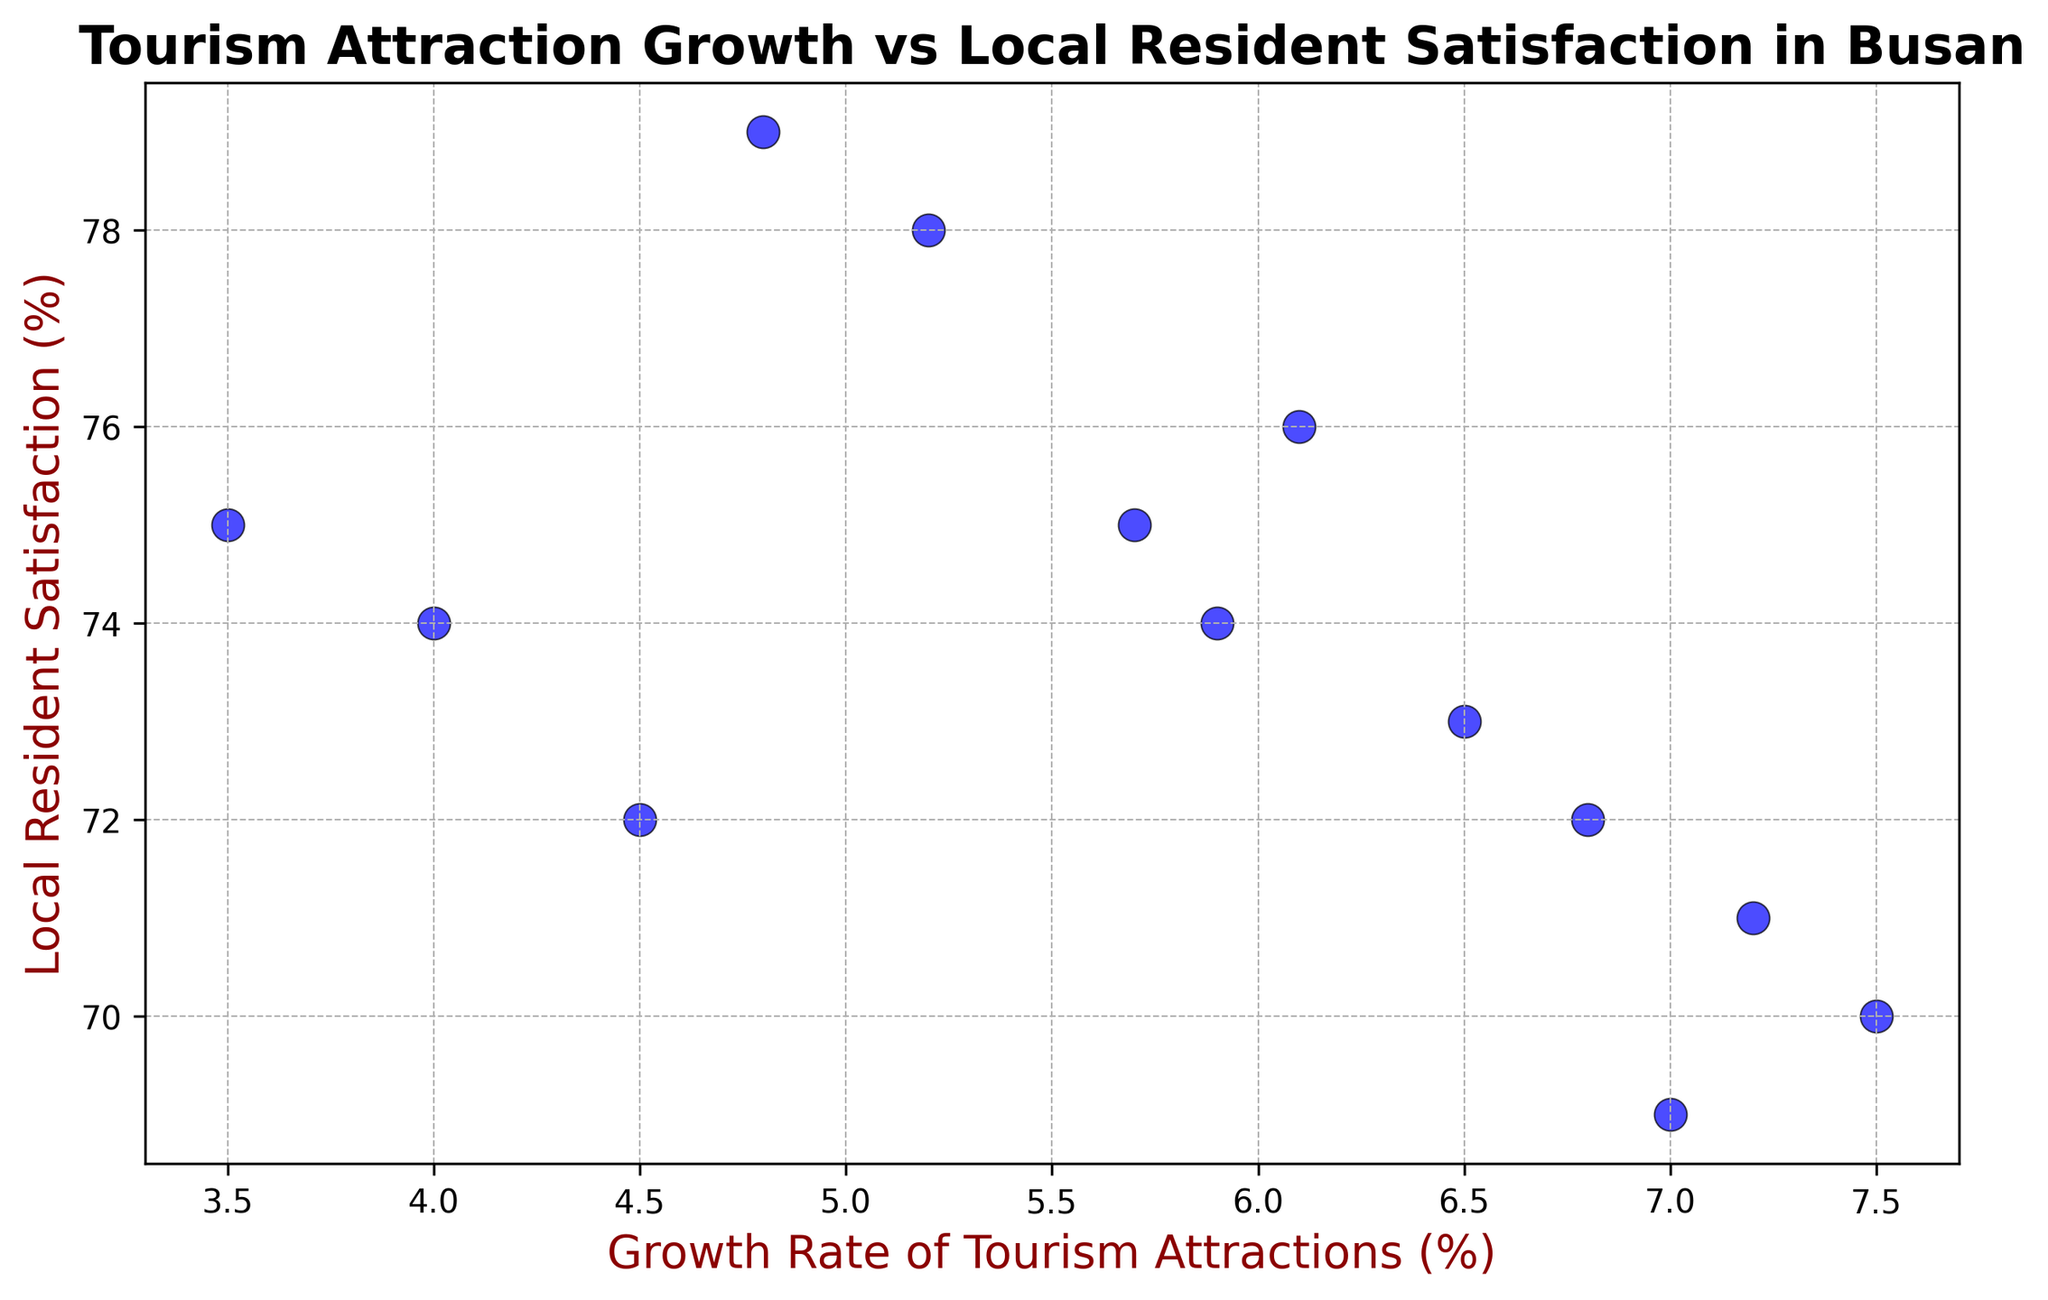What is the general trend between the growth rate of tourism attractions and local resident satisfaction? The plot shows that as the growth rate of tourism attractions increases, the local resident satisfaction decreases. This inverse relationship is evident from the scatter plot where points with higher growth rates correspond to lower satisfaction percentages.
Answer: Inverse relationship Which year had the highest growth rate of tourism attractions? From the scatter plot, the highest growth rate of tourism attractions is visible around the data point for 2018, where the growth rate is 7.5%.
Answer: 2018 Is there a year where both the growth rate of tourism attractions and local resident satisfaction are both relatively low? The scatter plot shows that in the year 2022, the growth rate of tourism attractions is at its lowest (3.5%) and the local resident satisfaction is relatively high compared to previous years, but not the highest (around 75%). For the lowest satisfaction as well, the year 2019 had a growth rate of 7.0% and satisfaction of 69%. Observing these points indicates they represent extremes in growth rate or satisfaction individually but not together. You should recheck the specifics to identify the lowest points of both.
Answer: No During which year was local resident satisfaction the highest, and what was the corresponding growth rate of tourism attractions? Referring to the scatter plot, the highest local resident satisfaction can be around 79%, which corresponds to the year 2012. The corresponding growth rate of tourism attractions for 2012 is approximately 4.8%.
Answer: 2012, 4.8% What is the average growth rate of tourism attractions for the years when local resident satisfaction was above 73%? Local resident satisfaction was above 73% in the years 2010 (78%), 2011 (76%), 2012 (79%), 2013 (75%), 2020 (72%), 2021 (74%), and 2022 (75%). The corresponding growth rates are 5.2%, 6.1%, 4.8%, 5.7%, 4.5%, 4.0%, and 3.5%. To find the average, add these growth rates and divide by the number of years. The sum of growth rates is 33.8, and dividing by 7 (the number of years) gives an average growth rate of 4.83%.
Answer: 4.83% How does the local resident satisfaction compare between the years with the lowest and highest growth rates of tourism attractions? The lowest growth rate of tourism attractions is 3.5% in 2022, with a local resident satisfaction of 75%. The highest growth rate is 7.5% in 2018, with a local resident satisfaction of 70%. Therefore, the satisfaction is higher in the year with the lowest growth rate compared to the year with the highest growth rate.
Answer: Higher in the year with lowest growth rate Is there any year where the local resident satisfaction is exactly 74%, and if yes, what is the growth rate of tourism attractions for that year? From the scatter plot, the years with a local resident satisfaction of exactly 74% are 2015 and 2021. The corresponding growth rates for those years are 5.9% and 4.0%, respectively.
Answer: Yes, 5.9% and 4.0% 